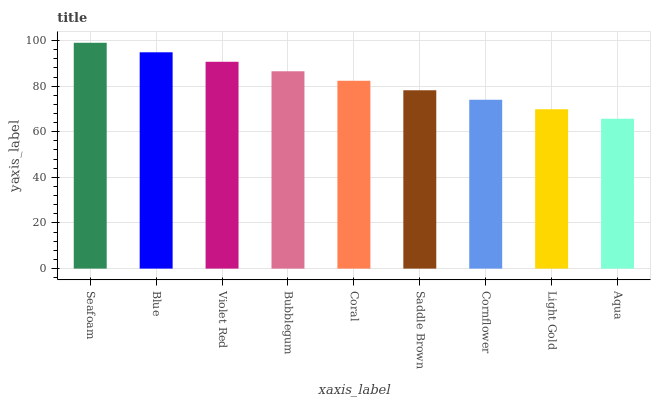Is Aqua the minimum?
Answer yes or no. Yes. Is Seafoam the maximum?
Answer yes or no. Yes. Is Blue the minimum?
Answer yes or no. No. Is Blue the maximum?
Answer yes or no. No. Is Seafoam greater than Blue?
Answer yes or no. Yes. Is Blue less than Seafoam?
Answer yes or no. Yes. Is Blue greater than Seafoam?
Answer yes or no. No. Is Seafoam less than Blue?
Answer yes or no. No. Is Coral the high median?
Answer yes or no. Yes. Is Coral the low median?
Answer yes or no. Yes. Is Aqua the high median?
Answer yes or no. No. Is Blue the low median?
Answer yes or no. No. 